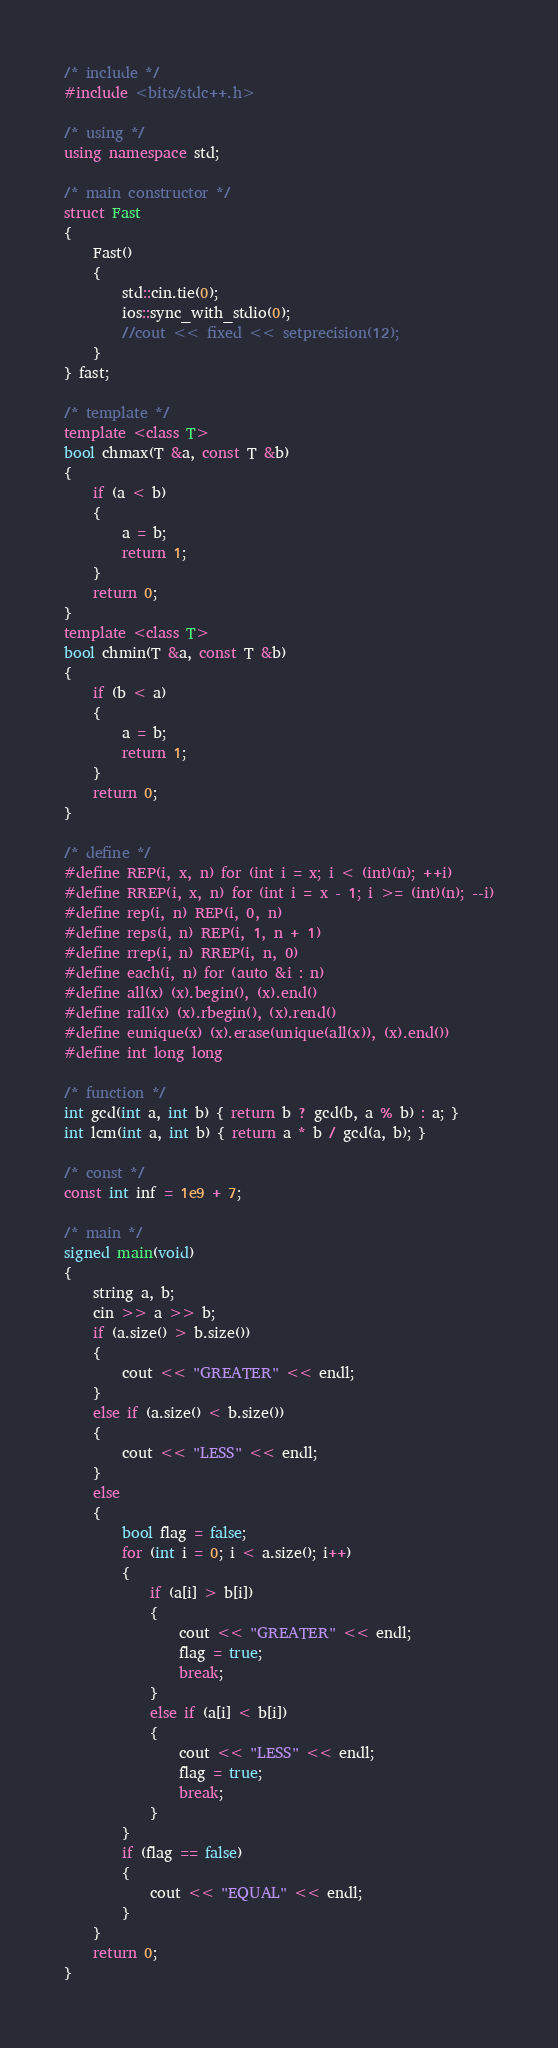Convert code to text. <code><loc_0><loc_0><loc_500><loc_500><_C++_>/* include */
#include <bits/stdc++.h>

/* using */
using namespace std;

/* main constructor */
struct Fast
{
    Fast()
    {
        std::cin.tie(0);
        ios::sync_with_stdio(0);
        //cout << fixed << setprecision(12);
    }
} fast;

/* template */
template <class T>
bool chmax(T &a, const T &b)
{
    if (a < b)
    {
        a = b;
        return 1;
    }
    return 0;
}
template <class T>
bool chmin(T &a, const T &b)
{
    if (b < a)
    {
        a = b;
        return 1;
    }
    return 0;
}

/* define */
#define REP(i, x, n) for (int i = x; i < (int)(n); ++i)
#define RREP(i, x, n) for (int i = x - 1; i >= (int)(n); --i)
#define rep(i, n) REP(i, 0, n)
#define reps(i, n) REP(i, 1, n + 1)
#define rrep(i, n) RREP(i, n, 0)
#define each(i, n) for (auto &i : n)
#define all(x) (x).begin(), (x).end()
#define rall(x) (x).rbegin(), (x).rend()
#define eunique(x) (x).erase(unique(all(x)), (x).end())
#define int long long

/* function */
int gcd(int a, int b) { return b ? gcd(b, a % b) : a; }
int lcm(int a, int b) { return a * b / gcd(a, b); }

/* const */
const int inf = 1e9 + 7;

/* main */
signed main(void)
{
    string a, b;
    cin >> a >> b;
    if (a.size() > b.size())
    {
        cout << "GREATER" << endl;
    }
    else if (a.size() < b.size())
    {
        cout << "LESS" << endl;
    }
    else
    {
        bool flag = false;
        for (int i = 0; i < a.size(); i++)
        {
            if (a[i] > b[i])
            {
                cout << "GREATER" << endl;
                flag = true;
                break;
            }
            else if (a[i] < b[i])
            {
                cout << "LESS" << endl;
                flag = true;
                break;
            }
        }
        if (flag == false)
        {
            cout << "EQUAL" << endl;
        }
    }
    return 0;
}</code> 